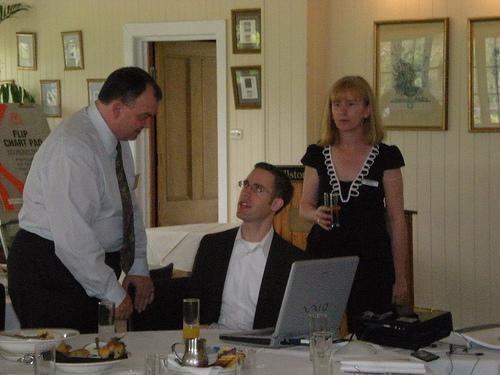Where is this venue likely to be?
Choose the right answer and clarify with the format: 'Answer: answer
Rationale: rationale.'
Options: Home, conference room, office, restaurant. Answer: conference room.
Rationale: The venue is a conference room. 